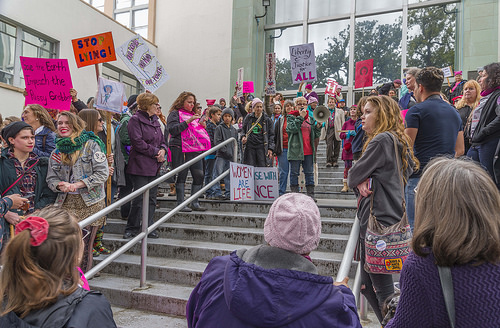<image>
Can you confirm if the sign is on the building? No. The sign is not positioned on the building. They may be near each other, but the sign is not supported by or resting on top of the building. Is there a man behind the woman? Yes. From this viewpoint, the man is positioned behind the woman, with the woman partially or fully occluding the man. 